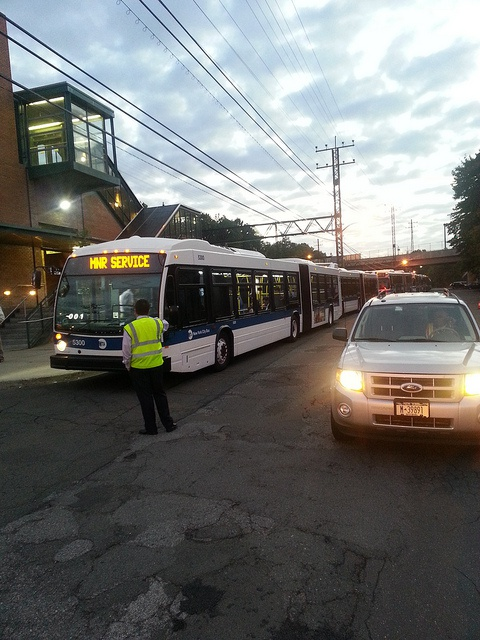Describe the objects in this image and their specific colors. I can see bus in lightblue, black, gray, darkgray, and lightgray tones, car in lightblue, gray, darkgray, lightgray, and black tones, people in lightblue, black, gray, and olive tones, people in gray and lightblue tones, and bus in lightblue, black, maroon, and brown tones in this image. 